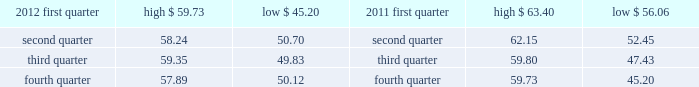( 5 ) we occupy approximately 350000 square feet of the one north end building .
( 6 ) this property is owned by board of trade investment company ( botic ) .
Kcbt maintains a 51% ( 51 % ) controlling interest in botic .
We also lease other office space around the world and have also partnered with major global telecommunications carriers in connection with our telecommunications hubs whereby we place data cabinets within the carriers 2019 existing secured data centers .
We believe our facilities are adequate for our current operations and that additional space can be obtained if needed .
Item 3 .
Legal proceedings see 201clegal and regulatory matters 201d in note 14 .
Contingencies to the consolidated financial statements beginning on page 91 for cme group 2019s legal proceedings disclosure which is incorporated herein by reference .
Item 4 .
Mine safety disclosures not applicable .
Part ii item 5 .
Market for registrant 2019s common equity , related stockholder matters and issuer purchases of equity securities class a common stock our class a common stock is currently listed on nasdaq under the ticker symbol 201ccme . 201d as of february 13 , 2013 , there were approximately 3106 holders of record of our class a common stock .
In may 2012 , the company 2019s board of directors declared a five-for-one split of its class a common stock effected by way of a stock dividend to its class a and class b shareholders .
The stock split was effective july 20 , 2012 for all shareholders of record on july 10 , 2012 .
As a result of the stock split , all amounts related to shares and per share amounts have been retroactively restated .
The table sets forth the high and low sales prices per share of our class a common stock on a quarterly basis , as reported on nasdaq. .
Class b common stock our class b common stock is not listed on a national securities exchange or traded in an organized over- the-counter market .
Each class of our class b common stock is associated with a membership in a specific division of our cme exchange .
Cme 2019s rules provide exchange members with trading rights and the ability to use or lease these trading rights .
Each share of our class b common stock can be transferred only in connection with the transfer of the associated trading rights. .
What is the maximum change in share price during the fourth quarter of 2012? 
Computations: (57.89 - 50.12)
Answer: 7.77. 